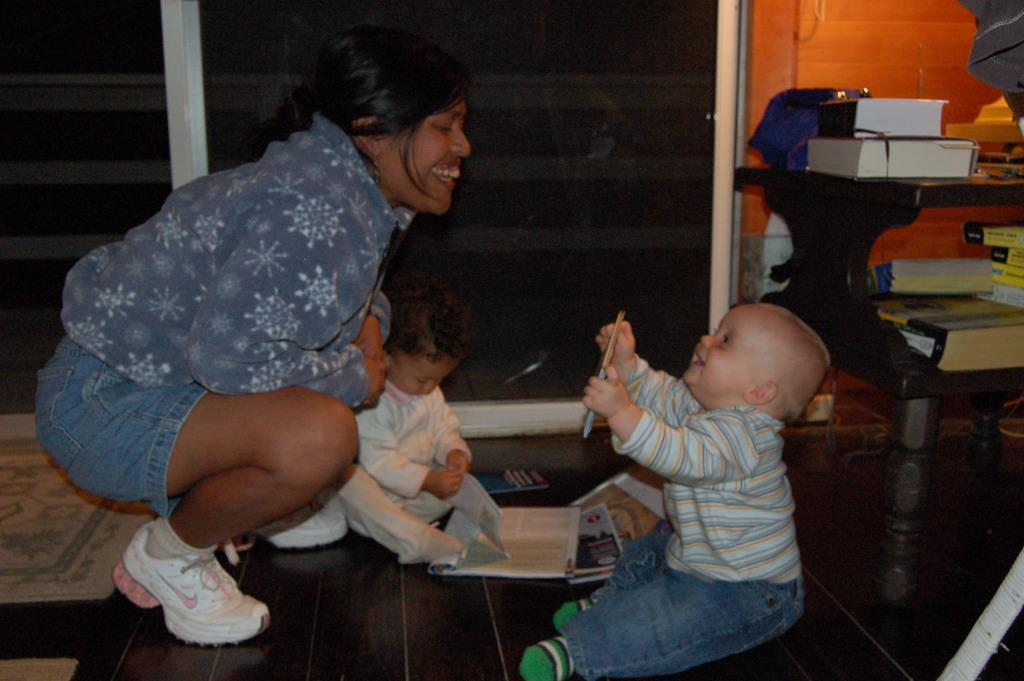Who is present in the image? There is a man in the image. What can be seen in the background of the image? There are two kids in the background of the image. What objects are on the table in the image? There are books on a table in the image. What architectural feature is visible in the image? There is a window in the image. What is another architectural feature visible in the image? There is a wall in the image. What time does the clock show in the image? There is no clock present in the image. What action are the kids performing in the image? The provided facts do not mention any specific action being performed by the kids in the image. 